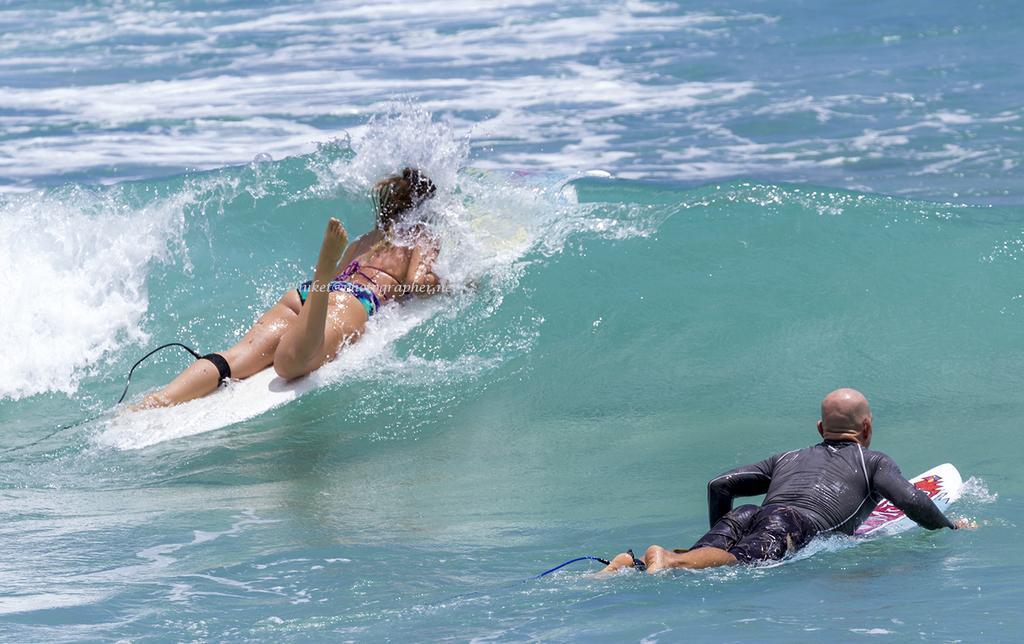Could you give a brief overview of what you see in this image? In this picture we can see a woman and a man surfing in the water. 